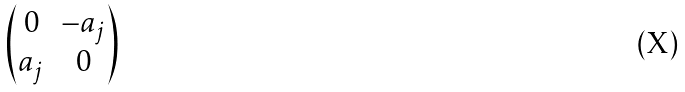<formula> <loc_0><loc_0><loc_500><loc_500>\begin{pmatrix} 0 & - a _ { j } \\ a _ { j } & 0 \end{pmatrix}</formula> 